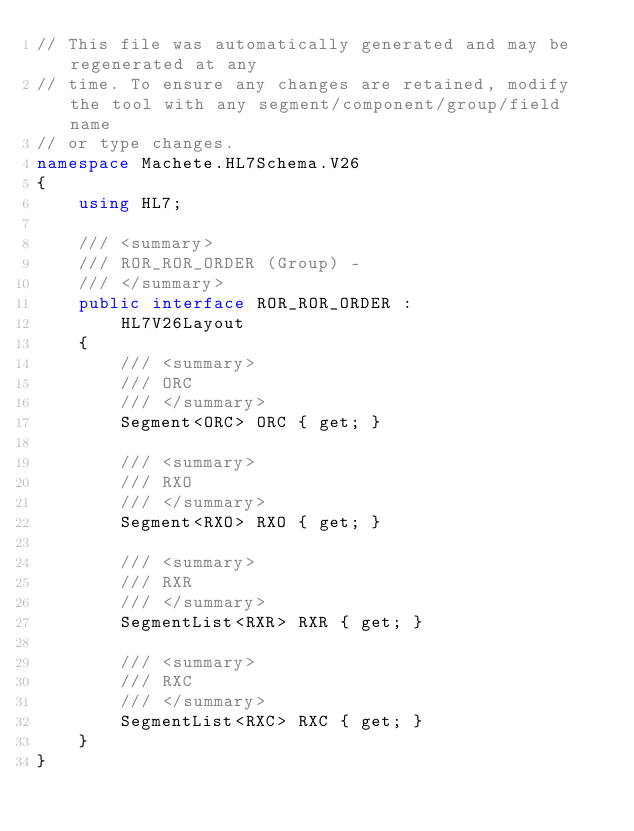<code> <loc_0><loc_0><loc_500><loc_500><_C#_>// This file was automatically generated and may be regenerated at any
// time. To ensure any changes are retained, modify the tool with any segment/component/group/field name
// or type changes.
namespace Machete.HL7Schema.V26
{
    using HL7;

    /// <summary>
    /// ROR_ROR_ORDER (Group) - 
    /// </summary>
    public interface ROR_ROR_ORDER :
        HL7V26Layout
    {
        /// <summary>
        /// ORC
        /// </summary>
        Segment<ORC> ORC { get; }

        /// <summary>
        /// RXO
        /// </summary>
        Segment<RXO> RXO { get; }

        /// <summary>
        /// RXR
        /// </summary>
        SegmentList<RXR> RXR { get; }

        /// <summary>
        /// RXC
        /// </summary>
        SegmentList<RXC> RXC { get; }
    }
}</code> 